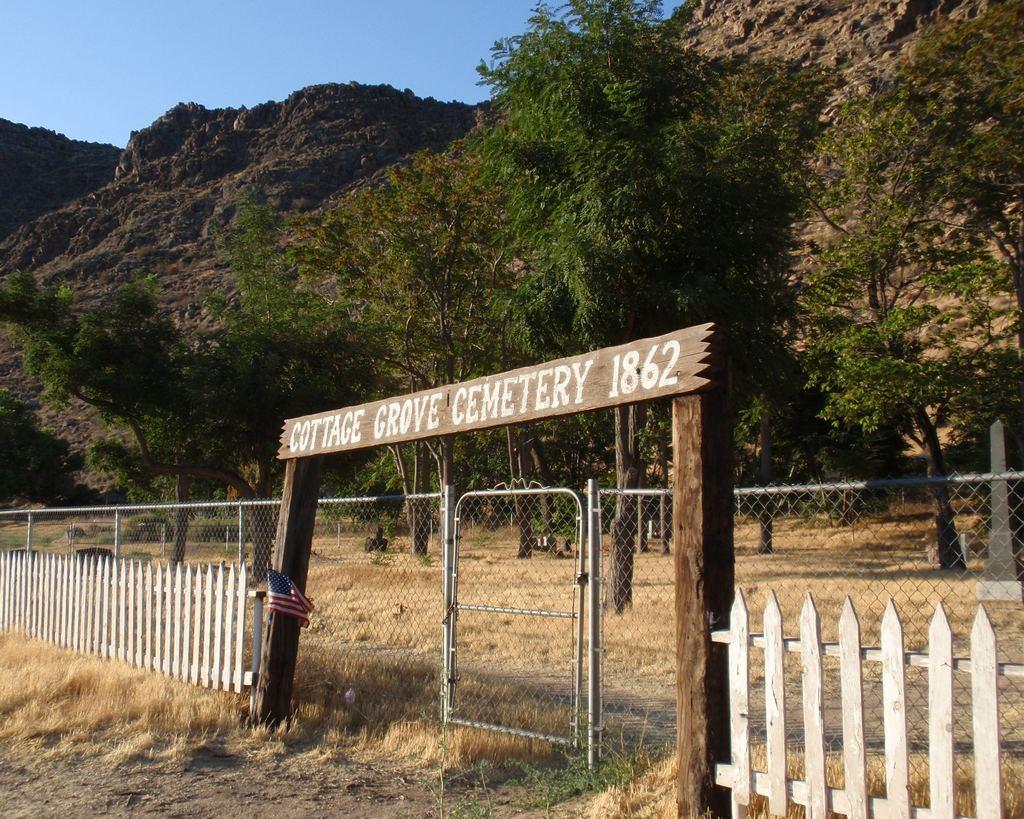Can you describe this image briefly? In this image there is fencing, in the background there are trees, mountain and the sky. 